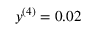Convert formula to latex. <formula><loc_0><loc_0><loc_500><loc_500>y ^ { ( 4 ) } = 0 . 0 2</formula> 